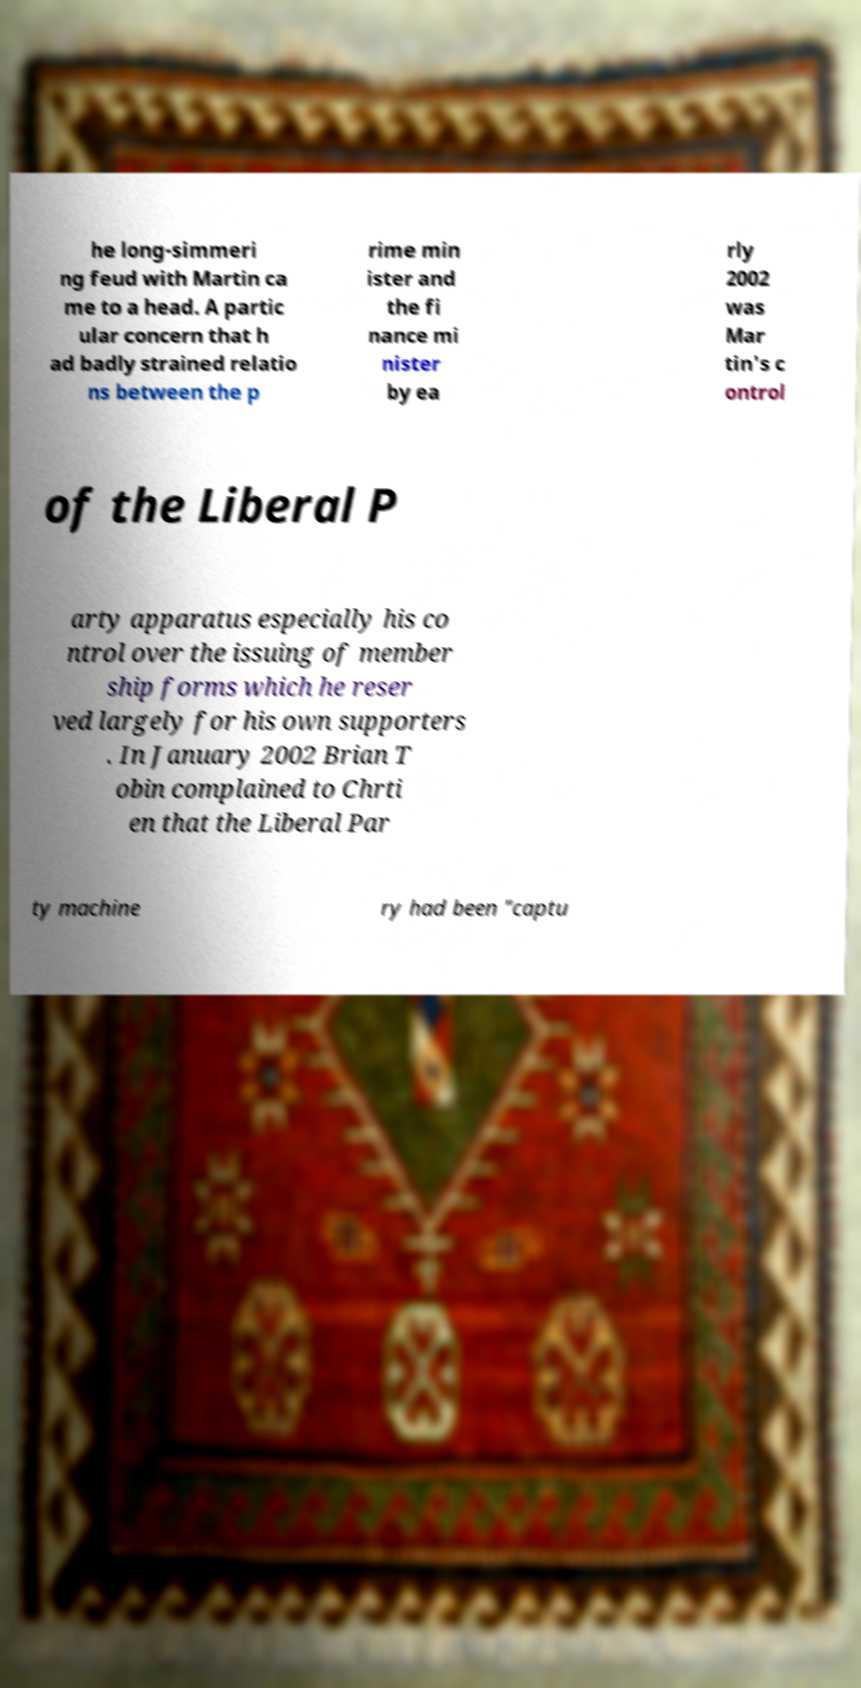For documentation purposes, I need the text within this image transcribed. Could you provide that? he long-simmeri ng feud with Martin ca me to a head. A partic ular concern that h ad badly strained relatio ns between the p rime min ister and the fi nance mi nister by ea rly 2002 was Mar tin's c ontrol of the Liberal P arty apparatus especially his co ntrol over the issuing of member ship forms which he reser ved largely for his own supporters . In January 2002 Brian T obin complained to Chrti en that the Liberal Par ty machine ry had been "captu 